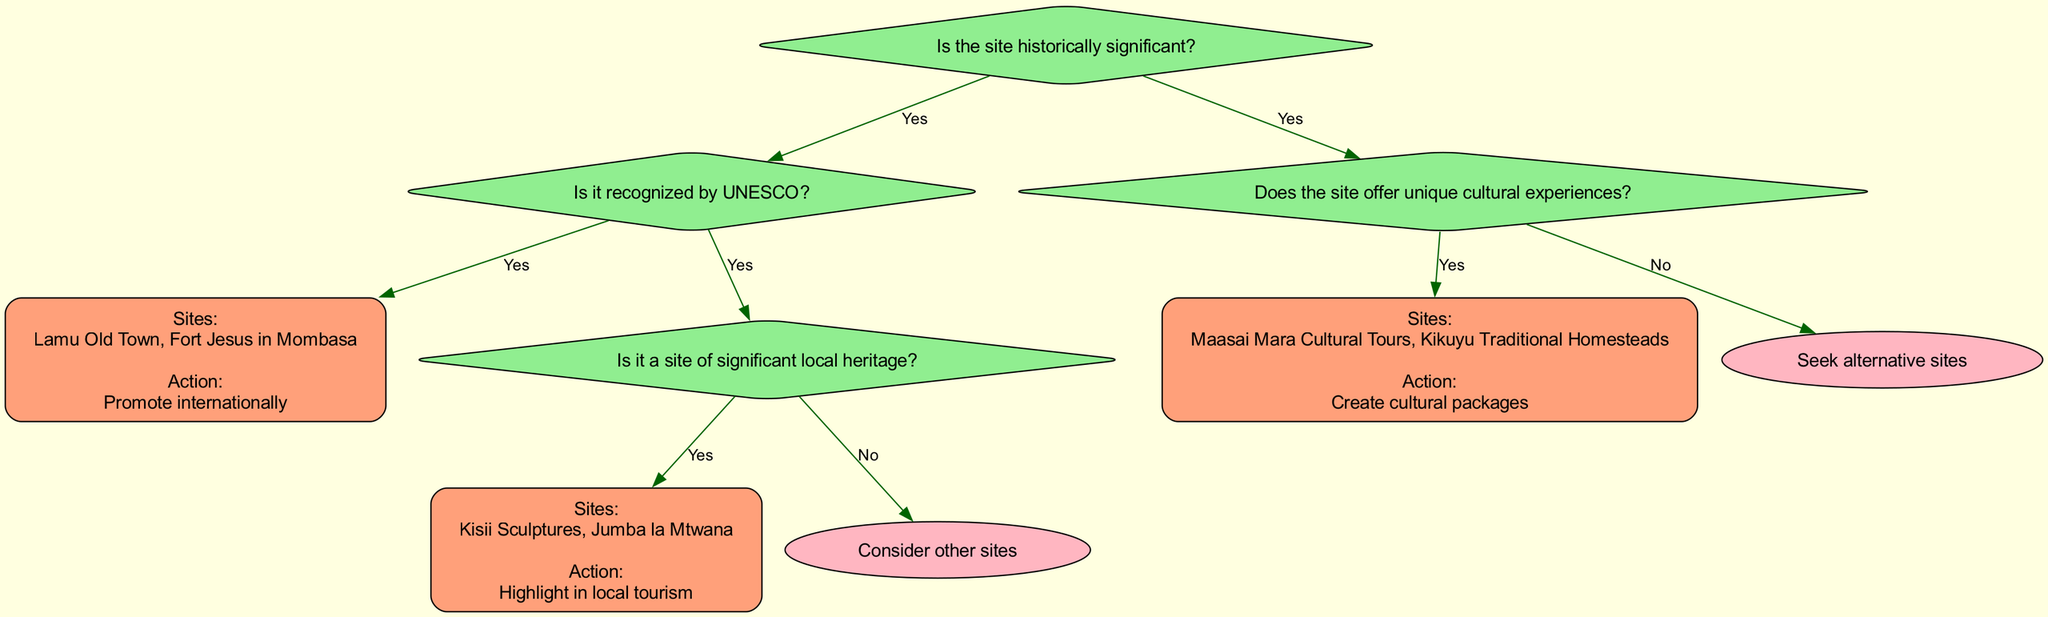What is the root question of the decision tree? The root question of the decision tree is "Is the site historically significant?" as it is the first question posed in the diagram structure.
Answer: Is the site historically significant? How many sites are recognized by UNESCO? According to the decision tree, there are two sites listed under the "Yes" branch for recognition by UNESCO, which are Lamu Old Town and Fort Jesus in Mombasa.
Answer: Two If the site is not historically significant, what type of experience does it need to provide? The decision tree indicates that if the site is not historically significant, it should offer unique cultural experiences, as outlined in the subsequent question.
Answer: Unique cultural experiences Which sites are listed under significant local heritage? The sites listed under the "Yes" branch for significant local heritage are Kisii Sculptures and Jumba la Mtwana, as specified in the respective node for that condition.
Answer: Kisii Sculptures, Jumba la Mtwana What action is recommended for UNESCO recognized sites? The action recommended for sites recognized by UNESCO, such as Lamu Old Town and Fort Jesus in Mombasa, is to "Promote internationally," as this is the stated action for that decision pathway.
Answer: Promote internationally What happens if a site offers no unique cultural experiences? If a site offers no unique cultural experiences, the decision tree advises to "Seek alternative sites," indicating a movement towards looking for other potential sites to showcase.
Answer: Seek alternative sites What is the next action after identifying a site of significant local heritage? After identifying a site of significant local heritage, the next action according to the tree is to "Highlight in local tourism," providing a clear follow-up to that decision pathway.
Answer: Highlight in local tourism How many total "Further Action" nodes are present in the diagram? The diagram contains four "Further Action" nodes, each associated with different decision paths from the initial questions, providing various actions based on the outcomes.
Answer: Four What does the decision tree suggest if a site is neither historically significant nor offers unique cultural experiences? The decision tree suggests to "Consider other sites" if the site is neither historically significant nor offers unique cultural experiences, as this leads to an alternative decision pathway.
Answer: Consider other sites 